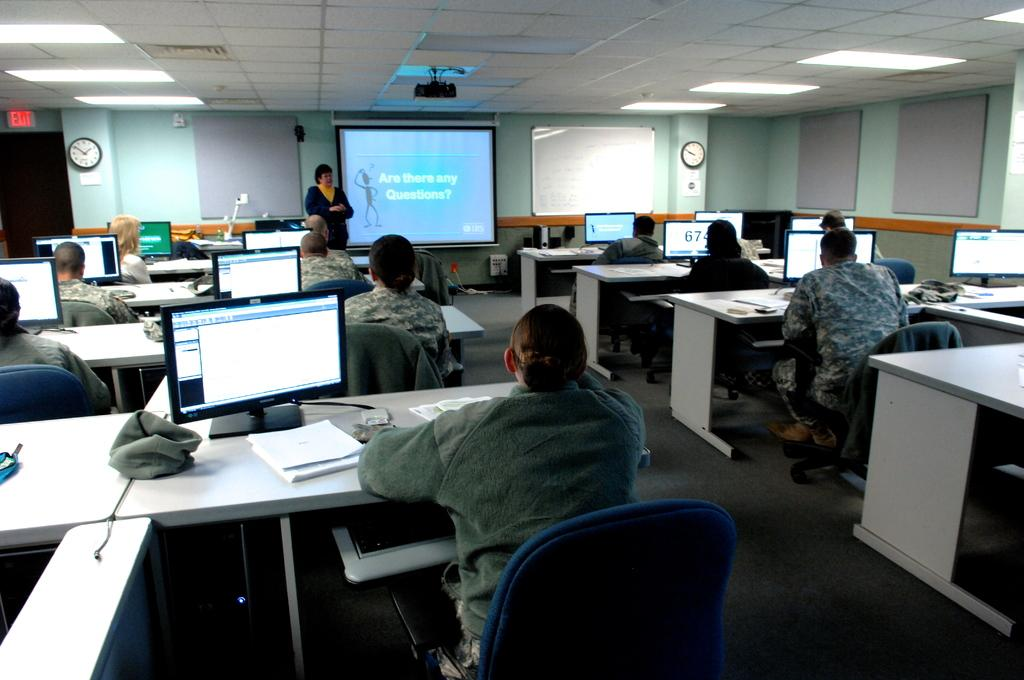<image>
Render a clear and concise summary of the photo. people sitting in front of a lecture and screen asking Are there any Questions 